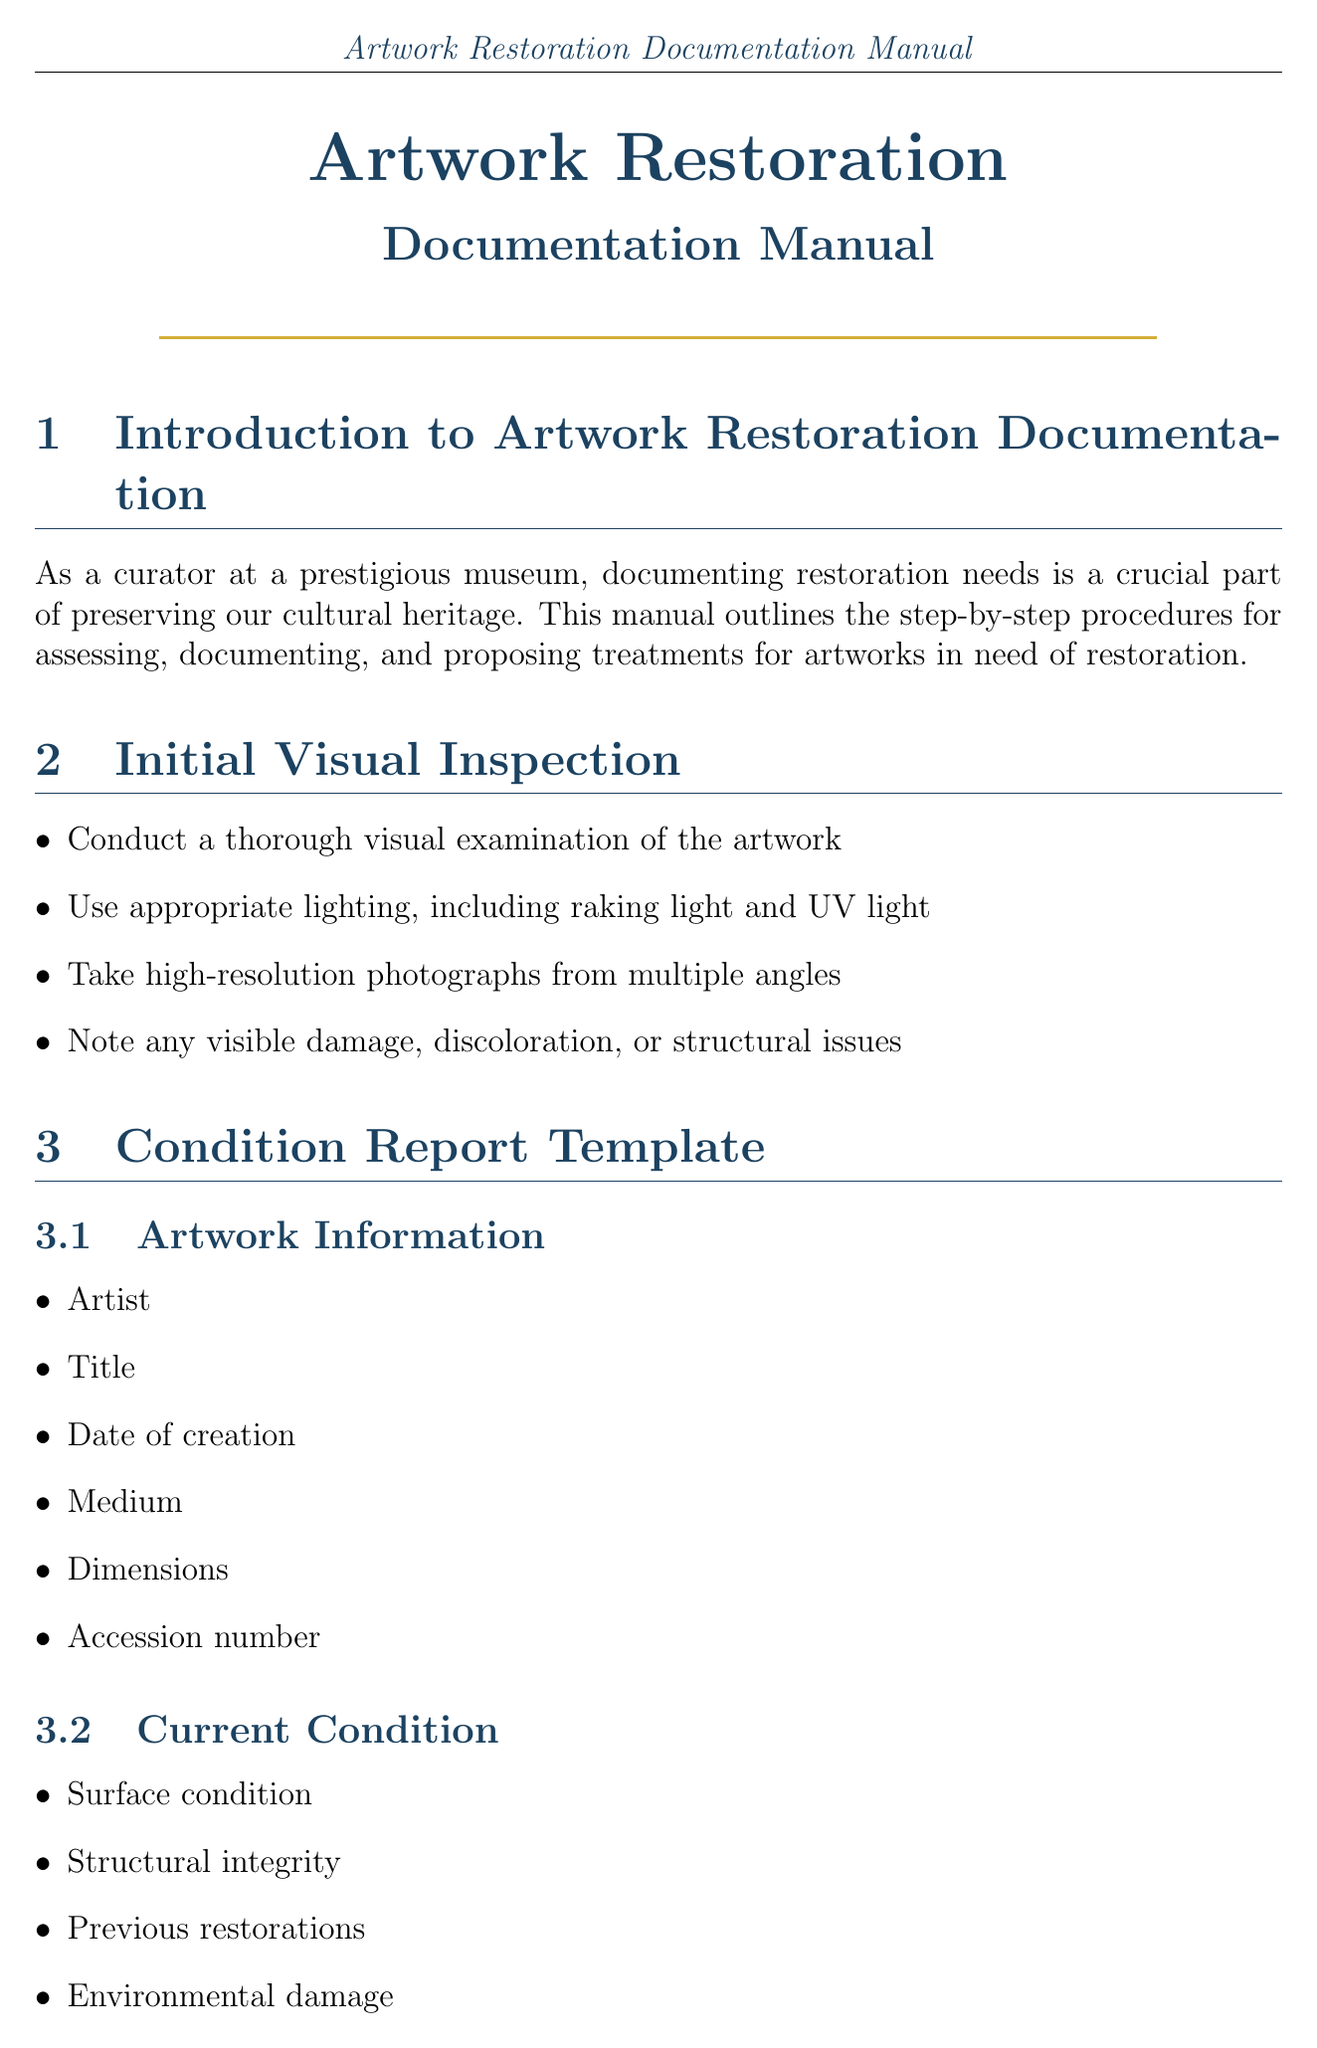what is the title of the document? The title of the document is stated at the beginning of the manual.
Answer: Artwork Restoration Documentation Manual what is the purpose of X-ray fluorescence? This is found in the scientific analysis section highlighting the purpose of specific techniques.
Answer: Identify pigments and materials which factors are considered for prioritization? These factors are listed under the prioritization guidelines section of the manual.
Answer: Severity of damage, Historical importance, Exhibition schedule, Available resources how many subsections are in the Treatment Proposal Template? The number of subsections can be counted in the treatment proposal template section.
Answer: 3 what is included in the Post-Treatment Documentation? This information is outlined in the post-treatment documentation section.
Answer: Before and after photographs, Detailed treatment report, Updated condition assessment, Recommendations for future care and display what should be documented in the decision-making process? Components needed for the documentation are listed in the corresponding section.
Answer: Meeting minutes, Correspondence with experts, Comparative case studies, Final approval documents when conducting an initial visual inspection, what tool should be used? This is found in the initial visual inspection section detailing appropriate methods.
Answer: UV light what is the justification section related to? This is covered in the treatment proposal template, explaining its significance.
Answer: Historical significance, Aesthetic considerations, Preservation needs 